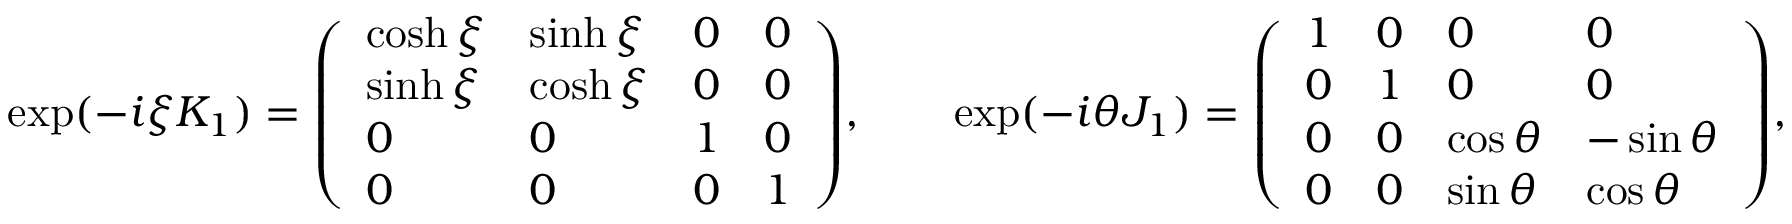Convert formula to latex. <formula><loc_0><loc_0><loc_500><loc_500>\exp ( - i \xi K _ { 1 } ) = { \left ( \begin{array} { l l l l } { \cosh \xi } & { \sinh \xi } & { 0 } & { 0 } \\ { \sinh \xi } & { \cosh \xi } & { 0 } & { 0 } \\ { 0 } & { 0 } & { 1 } & { 0 } \\ { 0 } & { 0 } & { 0 } & { 1 } \end{array} \right ) } , \quad \exp ( - i \theta J _ { 1 } ) = { \left ( \begin{array} { l l l l } { 1 } & { 0 } & { 0 } & { 0 } \\ { 0 } & { 1 } & { 0 } & { 0 } \\ { 0 } & { 0 } & { \cos \theta } & { - \sin \theta } \\ { 0 } & { 0 } & { \sin \theta } & { \cos \theta } \end{array} \right ) } ,</formula> 